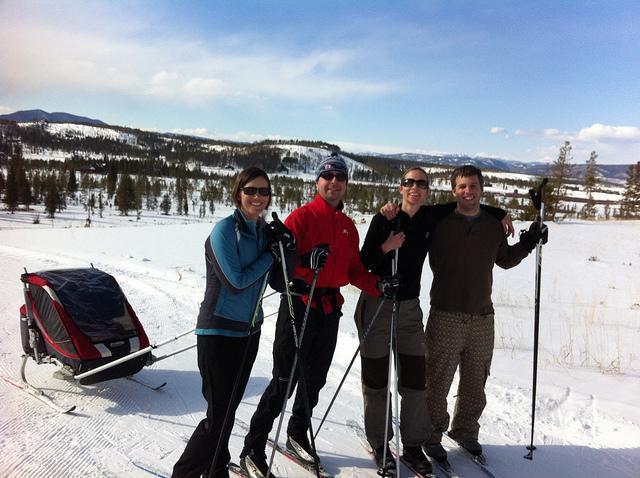How many people are looking at the camera?
Give a very brief answer. 4. How many people are visible?
Give a very brief answer. 4. How many cups are to the right of the plate?
Give a very brief answer. 0. 